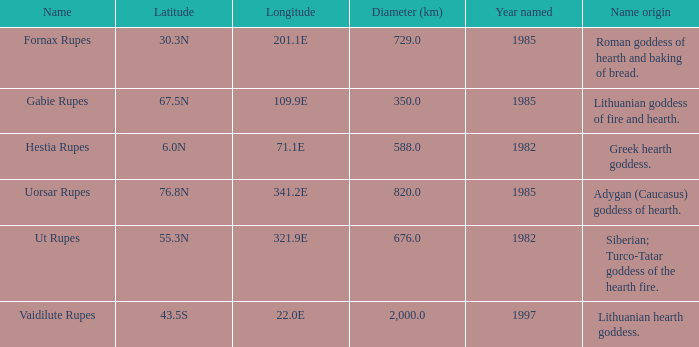At a longitude of 321.9e, what is the latitude of the features found? 55.3N. 